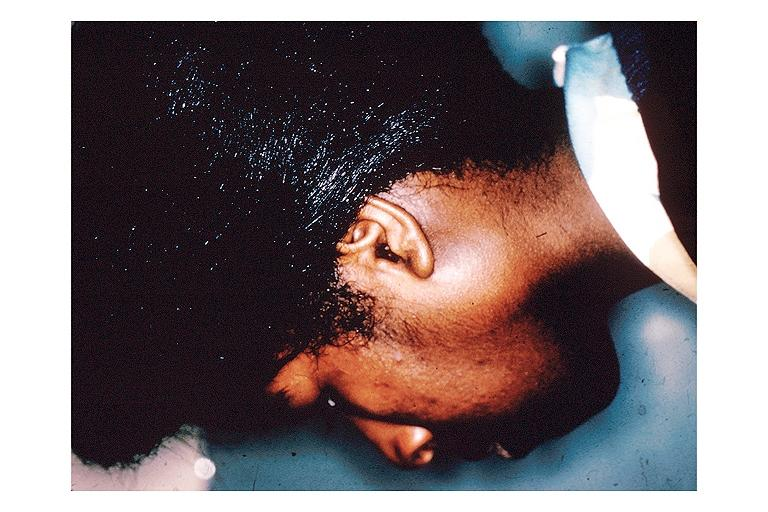does this protocol show sarcoidosis?
Answer the question using a single word or phrase. No 